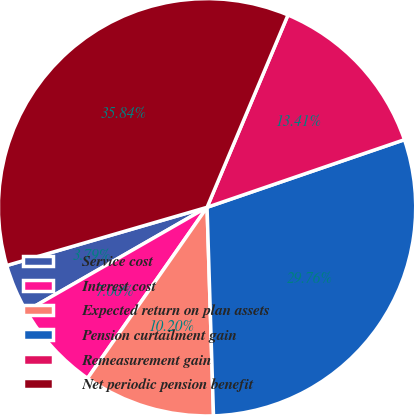Convert chart. <chart><loc_0><loc_0><loc_500><loc_500><pie_chart><fcel>Service cost<fcel>Interest cost<fcel>Expected return on plan assets<fcel>Pension curtailment gain<fcel>Remeasurement gain<fcel>Net periodic pension benefit<nl><fcel>3.79%<fcel>7.0%<fcel>10.2%<fcel>29.76%<fcel>13.41%<fcel>35.84%<nl></chart> 